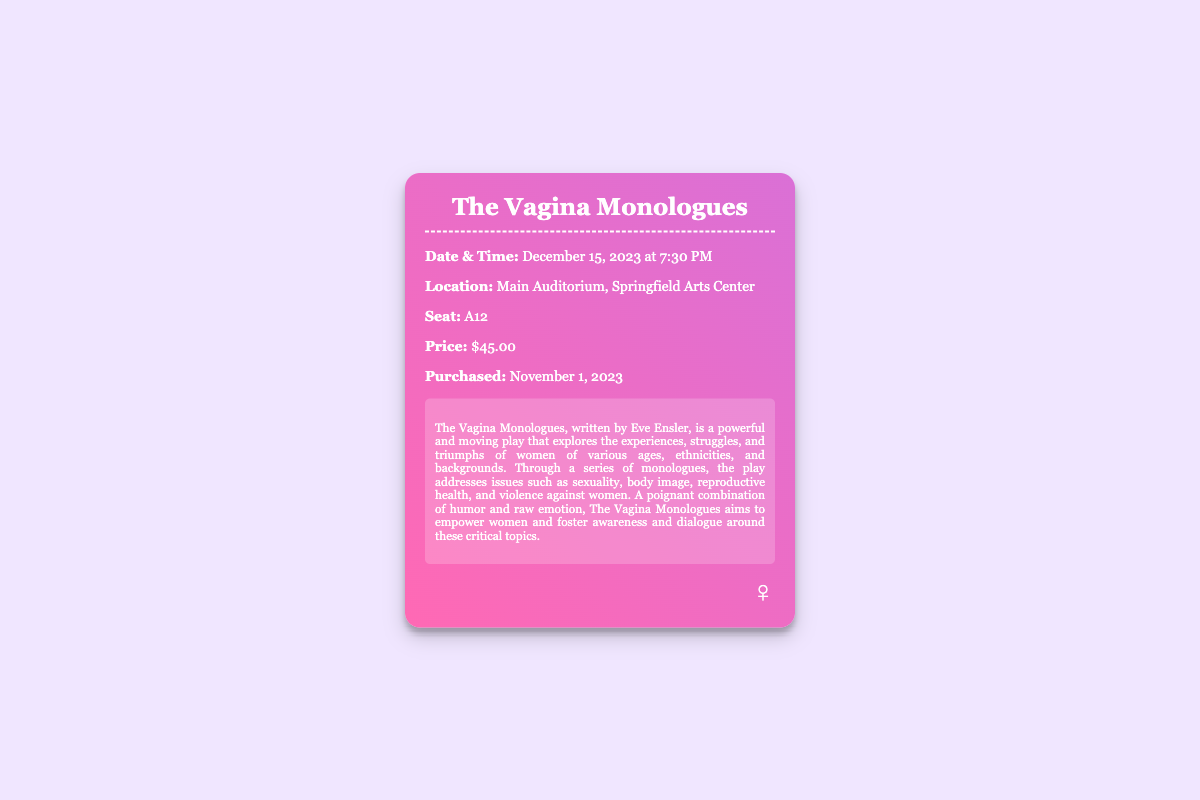What is the date of the performance? The date of the performance is explicitly mentioned in the document as December 15, 2023.
Answer: December 15, 2023 What is the time of the performance? The time of the performance is listed right after the date. It states that the performance starts at 7:30 PM.
Answer: 7:30 PM What is the seat number? The seat number is provided in the ticket information section as A12.
Answer: A12 What is the price of the ticket? The price is clearly stated in the document and it is $45.00.
Answer: $45.00 Who is the author of The Vagina Monologues? The author is named in the synopsis section of the document as Eve Ensler.
Answer: Eve Ensler What themes does The Vagina Monologues address? The synopsis describes themes including sexuality, body image, reproductive health, and violence against women.
Answer: Sexuality, body image, reproductive health, violence against women Where is the performance taking place? The location of the performance is given as the Main Auditorium, Springfield Arts Center.
Answer: Main Auditorium, Springfield Arts Center When was the ticket purchased? The purchase date is specifically noted in the document as November 1, 2023.
Answer: November 1, 2023 What is the purpose of The Vagina Monologues? The play aims to empower women and foster awareness and dialogue around critical topics.
Answer: Empower women and foster awareness and dialogue 